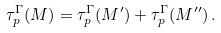Convert formula to latex. <formula><loc_0><loc_0><loc_500><loc_500>\tau ^ { \Gamma } _ { p } ( M ) = \tau ^ { \Gamma } _ { p } ( M ^ { \prime } ) + \tau ^ { \Gamma } _ { p } ( M ^ { \prime \prime } ) \, .</formula> 